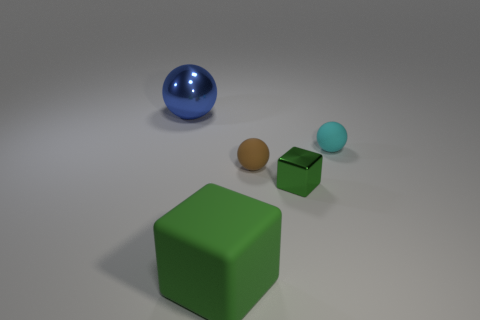There is a block that is the same color as the small metal object; what material is it?
Your answer should be compact. Rubber. What is the shape of the large metallic object?
Provide a short and direct response. Sphere. Is the number of small spheres behind the tiny metal thing greater than the number of small cyan metal cylinders?
Your response must be concise. Yes. There is a green thing that is behind the green matte thing; what is its shape?
Offer a very short reply. Cube. What number of other things are there of the same shape as the large blue metallic object?
Make the answer very short. 2. Does the small ball that is on the left side of the cyan rubber object have the same material as the cyan thing?
Ensure brevity in your answer.  Yes. Are there the same number of balls in front of the cyan thing and large objects to the left of the large green thing?
Provide a short and direct response. Yes. What is the size of the shiny thing that is in front of the blue thing?
Ensure brevity in your answer.  Small. Is there a cyan object that has the same material as the small brown object?
Your answer should be very brief. Yes. There is a cube that is on the left side of the tiny green cube; is its color the same as the small cube?
Provide a succinct answer. Yes. 